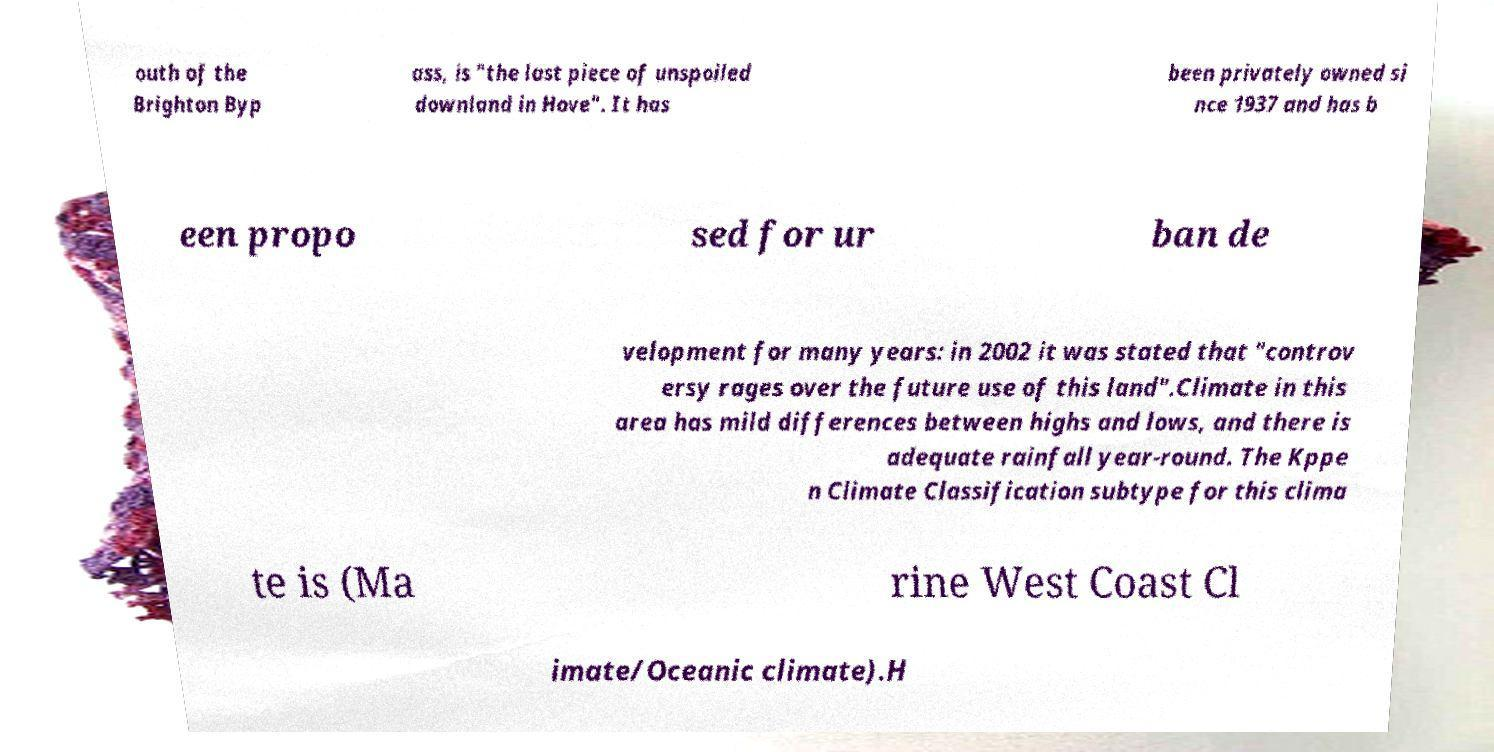There's text embedded in this image that I need extracted. Can you transcribe it verbatim? outh of the Brighton Byp ass, is "the last piece of unspoiled downland in Hove". It has been privately owned si nce 1937 and has b een propo sed for ur ban de velopment for many years: in 2002 it was stated that "controv ersy rages over the future use of this land".Climate in this area has mild differences between highs and lows, and there is adequate rainfall year-round. The Kppe n Climate Classification subtype for this clima te is (Ma rine West Coast Cl imate/Oceanic climate).H 